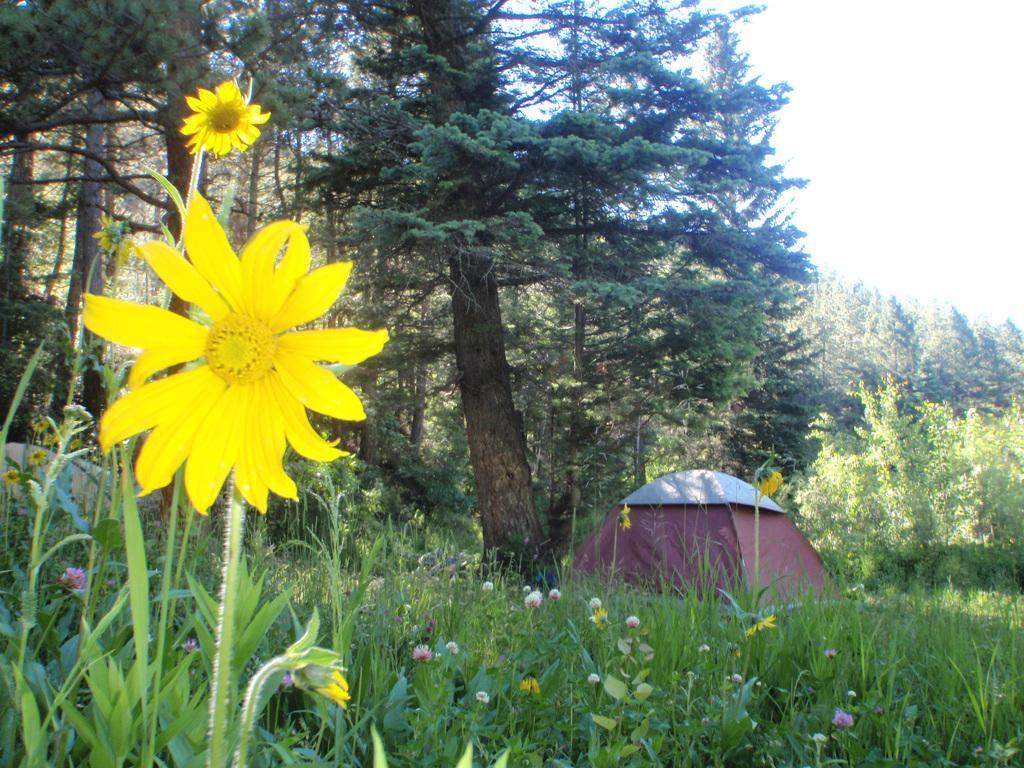In one or two sentences, can you explain what this image depicts? In this image I can see flower plants. These flowers are yellow in color. In the background I can see a tent, trees and the sky. 